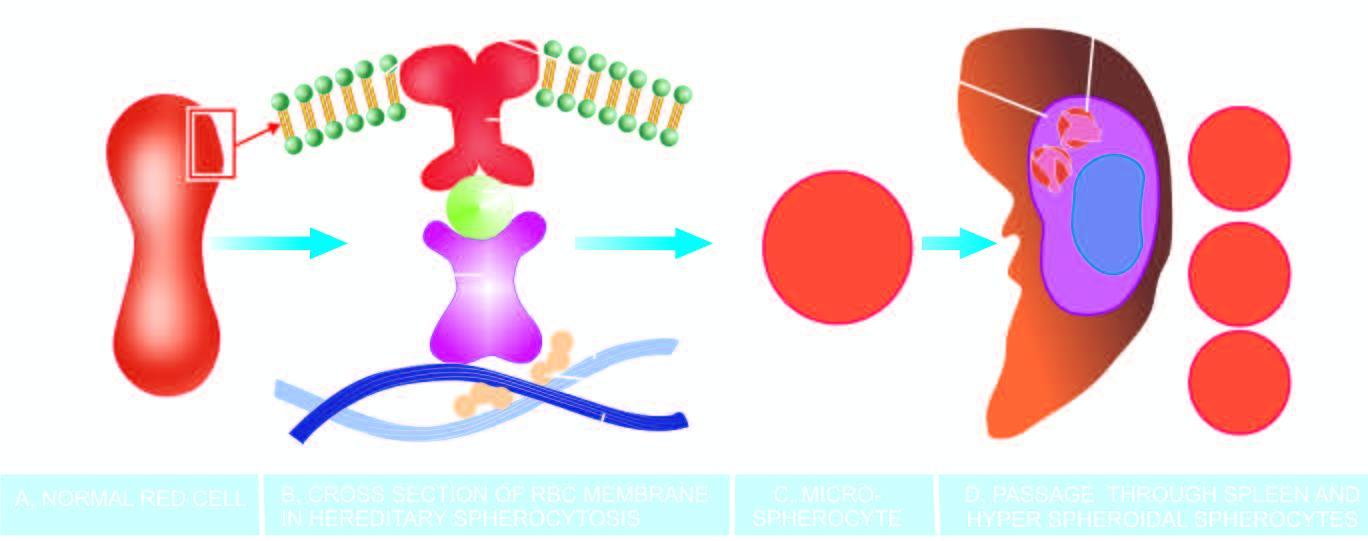when do d lose their cell membrane further?
Answer the question using a single word or phrase. During passage through the spleen 